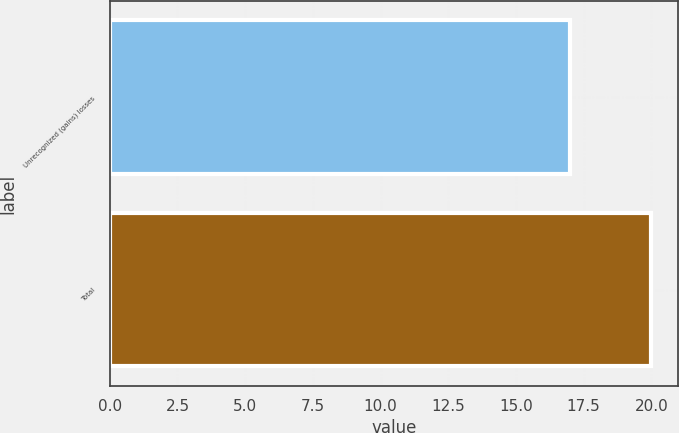Convert chart to OTSL. <chart><loc_0><loc_0><loc_500><loc_500><bar_chart><fcel>Unrecognized (gains) losses<fcel>Total<nl><fcel>17<fcel>20<nl></chart> 